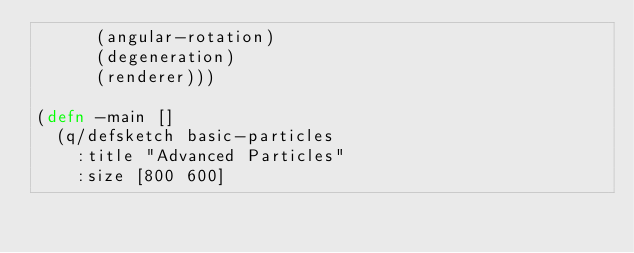<code> <loc_0><loc_0><loc_500><loc_500><_Clojure_>      (angular-rotation)
      (degeneration)
      (renderer)))

(defn -main []
  (q/defsketch basic-particles
    :title "Advanced Particles"
    :size [800 600]</code> 